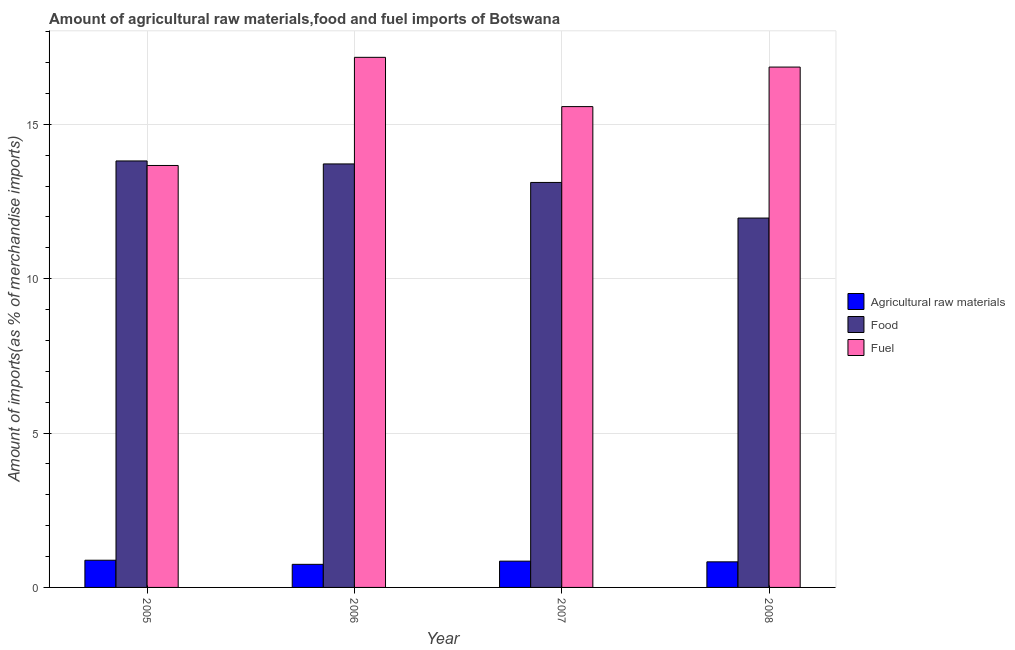How many different coloured bars are there?
Keep it short and to the point. 3. How many groups of bars are there?
Ensure brevity in your answer.  4. How many bars are there on the 4th tick from the left?
Keep it short and to the point. 3. How many bars are there on the 1st tick from the right?
Provide a succinct answer. 3. What is the label of the 2nd group of bars from the left?
Keep it short and to the point. 2006. In how many cases, is the number of bars for a given year not equal to the number of legend labels?
Make the answer very short. 0. What is the percentage of fuel imports in 2007?
Offer a very short reply. 15.57. Across all years, what is the maximum percentage of fuel imports?
Your answer should be compact. 17.17. Across all years, what is the minimum percentage of raw materials imports?
Provide a short and direct response. 0.75. In which year was the percentage of raw materials imports minimum?
Your answer should be very brief. 2006. What is the total percentage of food imports in the graph?
Keep it short and to the point. 52.6. What is the difference between the percentage of raw materials imports in 2005 and that in 2008?
Ensure brevity in your answer.  0.05. What is the difference between the percentage of fuel imports in 2007 and the percentage of raw materials imports in 2006?
Offer a terse response. -1.6. What is the average percentage of raw materials imports per year?
Offer a very short reply. 0.83. In the year 2005, what is the difference between the percentage of raw materials imports and percentage of food imports?
Your answer should be very brief. 0. What is the ratio of the percentage of fuel imports in 2005 to that in 2007?
Keep it short and to the point. 0.88. Is the percentage of raw materials imports in 2006 less than that in 2008?
Provide a succinct answer. Yes. What is the difference between the highest and the second highest percentage of food imports?
Your answer should be very brief. 0.1. What is the difference between the highest and the lowest percentage of raw materials imports?
Keep it short and to the point. 0.13. Is the sum of the percentage of raw materials imports in 2006 and 2008 greater than the maximum percentage of food imports across all years?
Ensure brevity in your answer.  Yes. What does the 2nd bar from the left in 2008 represents?
Make the answer very short. Food. What does the 3rd bar from the right in 2006 represents?
Ensure brevity in your answer.  Agricultural raw materials. Is it the case that in every year, the sum of the percentage of raw materials imports and percentage of food imports is greater than the percentage of fuel imports?
Provide a short and direct response. No. How many bars are there?
Offer a very short reply. 12. How many years are there in the graph?
Keep it short and to the point. 4. What is the difference between two consecutive major ticks on the Y-axis?
Your response must be concise. 5. Does the graph contain any zero values?
Your response must be concise. No. Does the graph contain grids?
Your answer should be compact. Yes. What is the title of the graph?
Keep it short and to the point. Amount of agricultural raw materials,food and fuel imports of Botswana. What is the label or title of the Y-axis?
Give a very brief answer. Amount of imports(as % of merchandise imports). What is the Amount of imports(as % of merchandise imports) in Agricultural raw materials in 2005?
Provide a succinct answer. 0.88. What is the Amount of imports(as % of merchandise imports) in Food in 2005?
Your response must be concise. 13.81. What is the Amount of imports(as % of merchandise imports) in Fuel in 2005?
Make the answer very short. 13.66. What is the Amount of imports(as % of merchandise imports) of Agricultural raw materials in 2006?
Make the answer very short. 0.75. What is the Amount of imports(as % of merchandise imports) in Food in 2006?
Your answer should be compact. 13.71. What is the Amount of imports(as % of merchandise imports) in Fuel in 2006?
Offer a terse response. 17.17. What is the Amount of imports(as % of merchandise imports) of Agricultural raw materials in 2007?
Offer a very short reply. 0.85. What is the Amount of imports(as % of merchandise imports) in Food in 2007?
Make the answer very short. 13.12. What is the Amount of imports(as % of merchandise imports) of Fuel in 2007?
Make the answer very short. 15.57. What is the Amount of imports(as % of merchandise imports) in Agricultural raw materials in 2008?
Keep it short and to the point. 0.83. What is the Amount of imports(as % of merchandise imports) in Food in 2008?
Keep it short and to the point. 11.96. What is the Amount of imports(as % of merchandise imports) in Fuel in 2008?
Offer a very short reply. 16.85. Across all years, what is the maximum Amount of imports(as % of merchandise imports) of Agricultural raw materials?
Offer a very short reply. 0.88. Across all years, what is the maximum Amount of imports(as % of merchandise imports) in Food?
Give a very brief answer. 13.81. Across all years, what is the maximum Amount of imports(as % of merchandise imports) in Fuel?
Your response must be concise. 17.17. Across all years, what is the minimum Amount of imports(as % of merchandise imports) of Agricultural raw materials?
Offer a very short reply. 0.75. Across all years, what is the minimum Amount of imports(as % of merchandise imports) of Food?
Give a very brief answer. 11.96. Across all years, what is the minimum Amount of imports(as % of merchandise imports) in Fuel?
Keep it short and to the point. 13.66. What is the total Amount of imports(as % of merchandise imports) of Agricultural raw materials in the graph?
Your answer should be compact. 3.31. What is the total Amount of imports(as % of merchandise imports) in Food in the graph?
Offer a very short reply. 52.6. What is the total Amount of imports(as % of merchandise imports) in Fuel in the graph?
Ensure brevity in your answer.  63.25. What is the difference between the Amount of imports(as % of merchandise imports) in Agricultural raw materials in 2005 and that in 2006?
Ensure brevity in your answer.  0.13. What is the difference between the Amount of imports(as % of merchandise imports) of Food in 2005 and that in 2006?
Your answer should be very brief. 0.1. What is the difference between the Amount of imports(as % of merchandise imports) of Fuel in 2005 and that in 2006?
Your answer should be very brief. -3.5. What is the difference between the Amount of imports(as % of merchandise imports) in Agricultural raw materials in 2005 and that in 2007?
Offer a terse response. 0.03. What is the difference between the Amount of imports(as % of merchandise imports) in Food in 2005 and that in 2007?
Your response must be concise. 0.7. What is the difference between the Amount of imports(as % of merchandise imports) of Fuel in 2005 and that in 2007?
Your response must be concise. -1.91. What is the difference between the Amount of imports(as % of merchandise imports) of Agricultural raw materials in 2005 and that in 2008?
Your response must be concise. 0.05. What is the difference between the Amount of imports(as % of merchandise imports) of Food in 2005 and that in 2008?
Offer a very short reply. 1.85. What is the difference between the Amount of imports(as % of merchandise imports) of Fuel in 2005 and that in 2008?
Your response must be concise. -3.19. What is the difference between the Amount of imports(as % of merchandise imports) in Agricultural raw materials in 2006 and that in 2007?
Your response must be concise. -0.1. What is the difference between the Amount of imports(as % of merchandise imports) of Food in 2006 and that in 2007?
Your answer should be very brief. 0.6. What is the difference between the Amount of imports(as % of merchandise imports) of Fuel in 2006 and that in 2007?
Give a very brief answer. 1.6. What is the difference between the Amount of imports(as % of merchandise imports) in Agricultural raw materials in 2006 and that in 2008?
Your answer should be very brief. -0.08. What is the difference between the Amount of imports(as % of merchandise imports) in Food in 2006 and that in 2008?
Offer a terse response. 1.75. What is the difference between the Amount of imports(as % of merchandise imports) of Fuel in 2006 and that in 2008?
Make the answer very short. 0.32. What is the difference between the Amount of imports(as % of merchandise imports) of Agricultural raw materials in 2007 and that in 2008?
Keep it short and to the point. 0.02. What is the difference between the Amount of imports(as % of merchandise imports) in Food in 2007 and that in 2008?
Your answer should be compact. 1.15. What is the difference between the Amount of imports(as % of merchandise imports) in Fuel in 2007 and that in 2008?
Keep it short and to the point. -1.28. What is the difference between the Amount of imports(as % of merchandise imports) in Agricultural raw materials in 2005 and the Amount of imports(as % of merchandise imports) in Food in 2006?
Offer a terse response. -12.83. What is the difference between the Amount of imports(as % of merchandise imports) of Agricultural raw materials in 2005 and the Amount of imports(as % of merchandise imports) of Fuel in 2006?
Make the answer very short. -16.29. What is the difference between the Amount of imports(as % of merchandise imports) in Food in 2005 and the Amount of imports(as % of merchandise imports) in Fuel in 2006?
Keep it short and to the point. -3.36. What is the difference between the Amount of imports(as % of merchandise imports) of Agricultural raw materials in 2005 and the Amount of imports(as % of merchandise imports) of Food in 2007?
Make the answer very short. -12.23. What is the difference between the Amount of imports(as % of merchandise imports) in Agricultural raw materials in 2005 and the Amount of imports(as % of merchandise imports) in Fuel in 2007?
Provide a succinct answer. -14.69. What is the difference between the Amount of imports(as % of merchandise imports) in Food in 2005 and the Amount of imports(as % of merchandise imports) in Fuel in 2007?
Give a very brief answer. -1.76. What is the difference between the Amount of imports(as % of merchandise imports) in Agricultural raw materials in 2005 and the Amount of imports(as % of merchandise imports) in Food in 2008?
Your answer should be very brief. -11.08. What is the difference between the Amount of imports(as % of merchandise imports) in Agricultural raw materials in 2005 and the Amount of imports(as % of merchandise imports) in Fuel in 2008?
Your answer should be very brief. -15.97. What is the difference between the Amount of imports(as % of merchandise imports) of Food in 2005 and the Amount of imports(as % of merchandise imports) of Fuel in 2008?
Offer a terse response. -3.04. What is the difference between the Amount of imports(as % of merchandise imports) in Agricultural raw materials in 2006 and the Amount of imports(as % of merchandise imports) in Food in 2007?
Your response must be concise. -12.37. What is the difference between the Amount of imports(as % of merchandise imports) of Agricultural raw materials in 2006 and the Amount of imports(as % of merchandise imports) of Fuel in 2007?
Your answer should be very brief. -14.82. What is the difference between the Amount of imports(as % of merchandise imports) of Food in 2006 and the Amount of imports(as % of merchandise imports) of Fuel in 2007?
Ensure brevity in your answer.  -1.86. What is the difference between the Amount of imports(as % of merchandise imports) in Agricultural raw materials in 2006 and the Amount of imports(as % of merchandise imports) in Food in 2008?
Ensure brevity in your answer.  -11.21. What is the difference between the Amount of imports(as % of merchandise imports) of Agricultural raw materials in 2006 and the Amount of imports(as % of merchandise imports) of Fuel in 2008?
Offer a very short reply. -16.1. What is the difference between the Amount of imports(as % of merchandise imports) of Food in 2006 and the Amount of imports(as % of merchandise imports) of Fuel in 2008?
Offer a terse response. -3.14. What is the difference between the Amount of imports(as % of merchandise imports) of Agricultural raw materials in 2007 and the Amount of imports(as % of merchandise imports) of Food in 2008?
Provide a short and direct response. -11.11. What is the difference between the Amount of imports(as % of merchandise imports) in Agricultural raw materials in 2007 and the Amount of imports(as % of merchandise imports) in Fuel in 2008?
Ensure brevity in your answer.  -16. What is the difference between the Amount of imports(as % of merchandise imports) in Food in 2007 and the Amount of imports(as % of merchandise imports) in Fuel in 2008?
Keep it short and to the point. -3.74. What is the average Amount of imports(as % of merchandise imports) in Agricultural raw materials per year?
Your response must be concise. 0.83. What is the average Amount of imports(as % of merchandise imports) of Food per year?
Your answer should be very brief. 13.15. What is the average Amount of imports(as % of merchandise imports) in Fuel per year?
Offer a terse response. 15.81. In the year 2005, what is the difference between the Amount of imports(as % of merchandise imports) of Agricultural raw materials and Amount of imports(as % of merchandise imports) of Food?
Your answer should be compact. -12.93. In the year 2005, what is the difference between the Amount of imports(as % of merchandise imports) of Agricultural raw materials and Amount of imports(as % of merchandise imports) of Fuel?
Give a very brief answer. -12.78. In the year 2005, what is the difference between the Amount of imports(as % of merchandise imports) in Food and Amount of imports(as % of merchandise imports) in Fuel?
Offer a terse response. 0.15. In the year 2006, what is the difference between the Amount of imports(as % of merchandise imports) in Agricultural raw materials and Amount of imports(as % of merchandise imports) in Food?
Ensure brevity in your answer.  -12.97. In the year 2006, what is the difference between the Amount of imports(as % of merchandise imports) of Agricultural raw materials and Amount of imports(as % of merchandise imports) of Fuel?
Provide a succinct answer. -16.42. In the year 2006, what is the difference between the Amount of imports(as % of merchandise imports) in Food and Amount of imports(as % of merchandise imports) in Fuel?
Keep it short and to the point. -3.45. In the year 2007, what is the difference between the Amount of imports(as % of merchandise imports) of Agricultural raw materials and Amount of imports(as % of merchandise imports) of Food?
Offer a very short reply. -12.26. In the year 2007, what is the difference between the Amount of imports(as % of merchandise imports) of Agricultural raw materials and Amount of imports(as % of merchandise imports) of Fuel?
Make the answer very short. -14.72. In the year 2007, what is the difference between the Amount of imports(as % of merchandise imports) of Food and Amount of imports(as % of merchandise imports) of Fuel?
Make the answer very short. -2.46. In the year 2008, what is the difference between the Amount of imports(as % of merchandise imports) of Agricultural raw materials and Amount of imports(as % of merchandise imports) of Food?
Offer a terse response. -11.13. In the year 2008, what is the difference between the Amount of imports(as % of merchandise imports) in Agricultural raw materials and Amount of imports(as % of merchandise imports) in Fuel?
Your answer should be compact. -16.02. In the year 2008, what is the difference between the Amount of imports(as % of merchandise imports) in Food and Amount of imports(as % of merchandise imports) in Fuel?
Offer a terse response. -4.89. What is the ratio of the Amount of imports(as % of merchandise imports) in Agricultural raw materials in 2005 to that in 2006?
Make the answer very short. 1.18. What is the ratio of the Amount of imports(as % of merchandise imports) of Fuel in 2005 to that in 2006?
Give a very brief answer. 0.8. What is the ratio of the Amount of imports(as % of merchandise imports) of Agricultural raw materials in 2005 to that in 2007?
Provide a succinct answer. 1.03. What is the ratio of the Amount of imports(as % of merchandise imports) of Food in 2005 to that in 2007?
Provide a short and direct response. 1.05. What is the ratio of the Amount of imports(as % of merchandise imports) of Fuel in 2005 to that in 2007?
Ensure brevity in your answer.  0.88. What is the ratio of the Amount of imports(as % of merchandise imports) of Agricultural raw materials in 2005 to that in 2008?
Ensure brevity in your answer.  1.06. What is the ratio of the Amount of imports(as % of merchandise imports) in Food in 2005 to that in 2008?
Keep it short and to the point. 1.15. What is the ratio of the Amount of imports(as % of merchandise imports) in Fuel in 2005 to that in 2008?
Your answer should be compact. 0.81. What is the ratio of the Amount of imports(as % of merchandise imports) in Agricultural raw materials in 2006 to that in 2007?
Give a very brief answer. 0.88. What is the ratio of the Amount of imports(as % of merchandise imports) of Food in 2006 to that in 2007?
Give a very brief answer. 1.05. What is the ratio of the Amount of imports(as % of merchandise imports) of Fuel in 2006 to that in 2007?
Keep it short and to the point. 1.1. What is the ratio of the Amount of imports(as % of merchandise imports) of Agricultural raw materials in 2006 to that in 2008?
Offer a very short reply. 0.9. What is the ratio of the Amount of imports(as % of merchandise imports) of Food in 2006 to that in 2008?
Provide a succinct answer. 1.15. What is the ratio of the Amount of imports(as % of merchandise imports) in Fuel in 2006 to that in 2008?
Provide a succinct answer. 1.02. What is the ratio of the Amount of imports(as % of merchandise imports) of Agricultural raw materials in 2007 to that in 2008?
Provide a succinct answer. 1.03. What is the ratio of the Amount of imports(as % of merchandise imports) in Food in 2007 to that in 2008?
Provide a short and direct response. 1.1. What is the ratio of the Amount of imports(as % of merchandise imports) of Fuel in 2007 to that in 2008?
Your answer should be compact. 0.92. What is the difference between the highest and the second highest Amount of imports(as % of merchandise imports) of Agricultural raw materials?
Provide a short and direct response. 0.03. What is the difference between the highest and the second highest Amount of imports(as % of merchandise imports) of Food?
Your answer should be very brief. 0.1. What is the difference between the highest and the second highest Amount of imports(as % of merchandise imports) of Fuel?
Your answer should be compact. 0.32. What is the difference between the highest and the lowest Amount of imports(as % of merchandise imports) of Agricultural raw materials?
Make the answer very short. 0.13. What is the difference between the highest and the lowest Amount of imports(as % of merchandise imports) of Food?
Your answer should be very brief. 1.85. What is the difference between the highest and the lowest Amount of imports(as % of merchandise imports) of Fuel?
Provide a short and direct response. 3.5. 